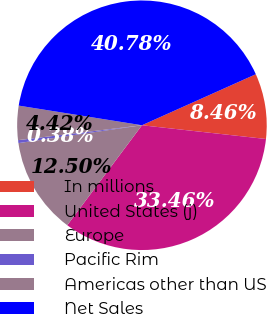Convert chart to OTSL. <chart><loc_0><loc_0><loc_500><loc_500><pie_chart><fcel>In millions<fcel>United States (j)<fcel>Europe<fcel>Pacific Rim<fcel>Americas other than US<fcel>Net Sales<nl><fcel>8.46%<fcel>33.46%<fcel>12.5%<fcel>0.38%<fcel>4.42%<fcel>40.78%<nl></chart> 